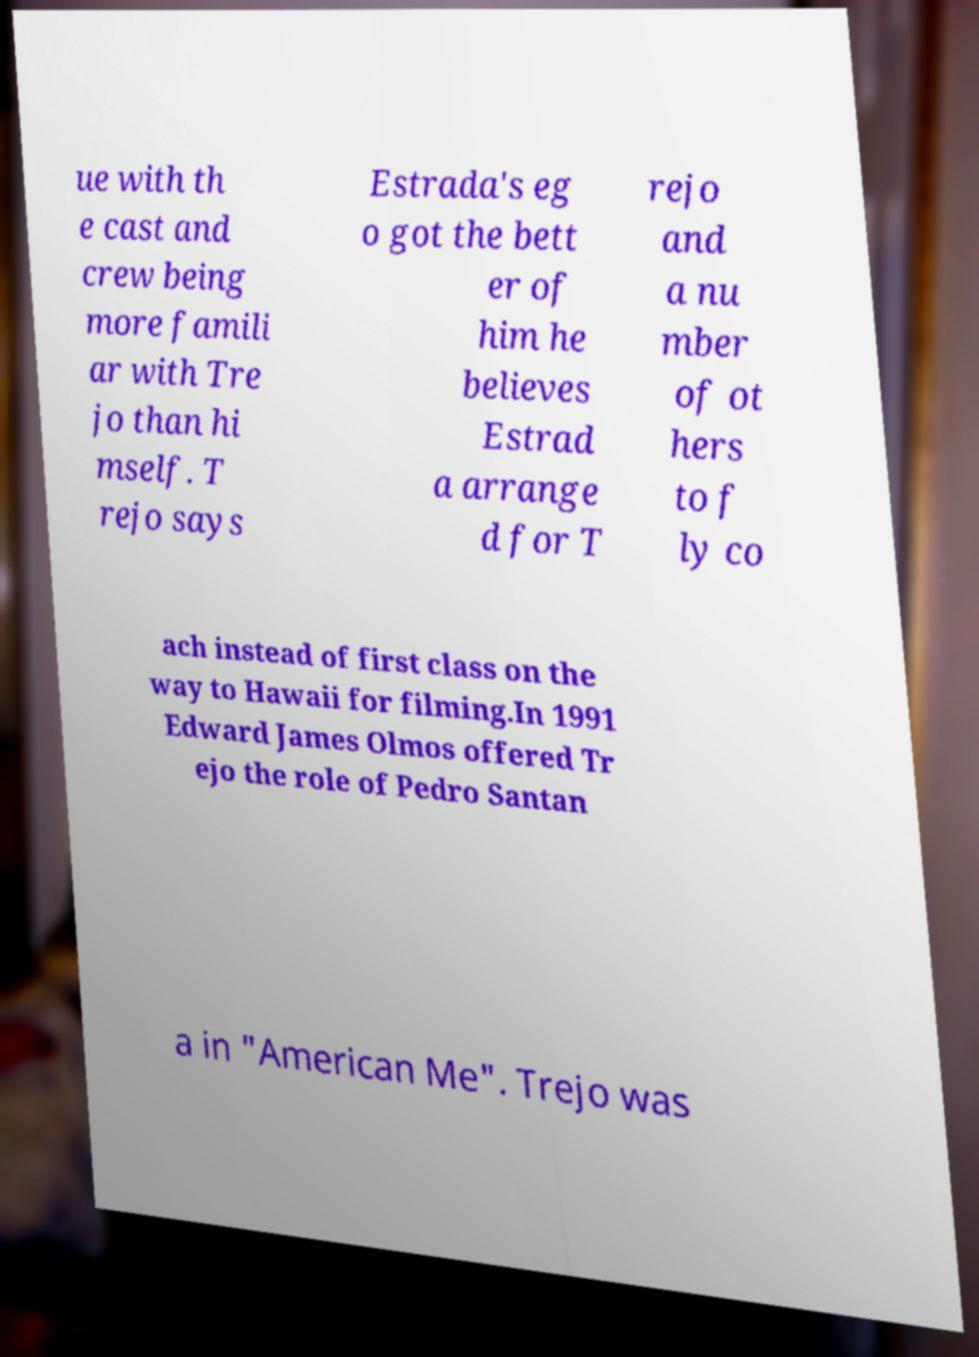For documentation purposes, I need the text within this image transcribed. Could you provide that? ue with th e cast and crew being more famili ar with Tre jo than hi mself. T rejo says Estrada's eg o got the bett er of him he believes Estrad a arrange d for T rejo and a nu mber of ot hers to f ly co ach instead of first class on the way to Hawaii for filming.In 1991 Edward James Olmos offered Tr ejo the role of Pedro Santan a in "American Me". Trejo was 